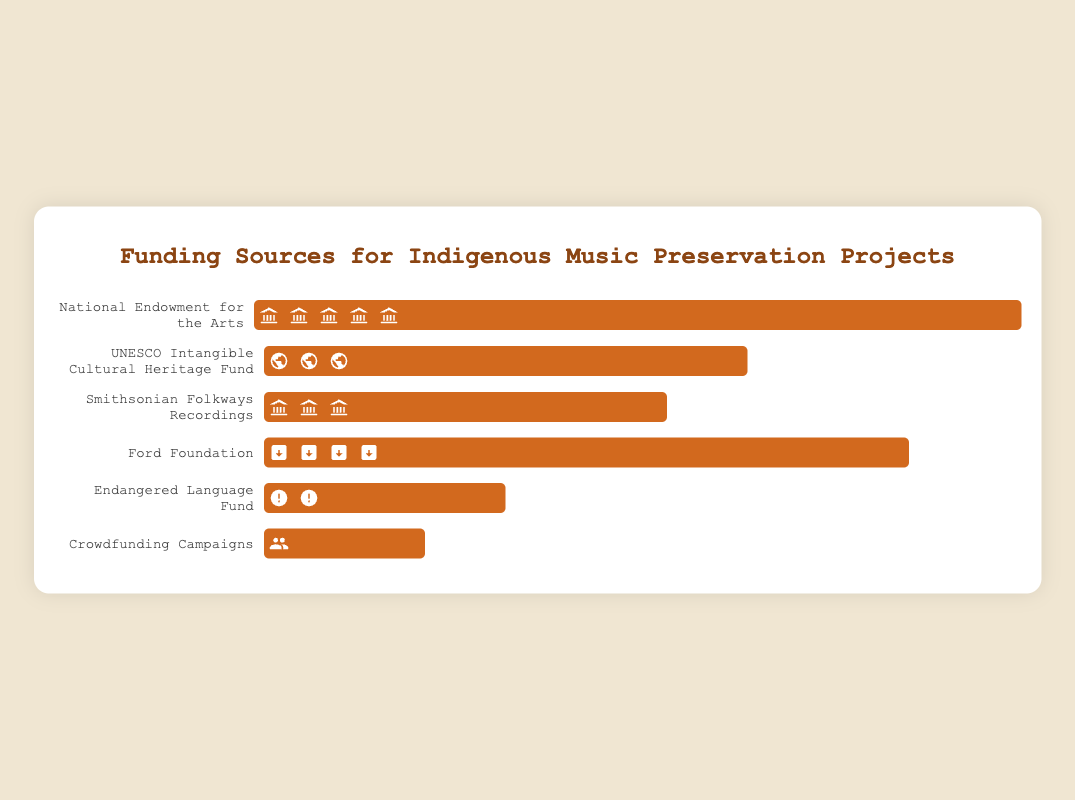What's the amount of funding provided by the National Endowment for the Arts? The bar related to the National Endowment for the Arts is the widest and corresponds to $500,000 according to the data provided.
Answer: $500,000 Which funding source provides the least amount of money? Comparing the lengths of the bars, the shortest one corresponds to Crowdfunding Campaigns, which has $100,000 as per the data provided.
Answer: Crowdfunding Campaigns How much more funding does the Ford Foundation provide compared to the Endangered Language Fund? The Ford Foundation provides $400,000 and the Endangered Language Fund provides $150,000. The difference is $400,000 - $150,000 = $250,000.
Answer: $250,000 If you combine the funding from Smithsonian Folkways Recordings and UNESCO Intangible Cultural Heritage Fund, what total amount do you get? The funding from Smithsonian Folkways Recordings is $250,000 and from UNESCO is $300,000. Combined, it is $250,000 + $300,000 =  $550,000.
Answer: $550,000 Which funding source uses an icon of a building with pillars? By looking at the bar labels and icons, the "institution" icon (building with pillars) corresponds to Smithsonian Folkways Recordings.
Answer: Smithsonian Folkways Recordings Rank the funding sources from highest to lowest amount of funding provided. The order from highest to lowest based on the bar lengths: National Endowment for the Arts ($500,000), Ford Foundation ($400,000), UNESCO Intangible Cultural Heritage Fund ($300,000), Smithsonian Folkways Recordings ($250,000), Endangered Language Fund ($150,000), Crowdfunding Campaigns ($100,000).
Answer: National Endowment for the Arts, Ford Foundation, UNESCO Intangible Cultural Heritage Fund, Smithsonian Folkways Recordings, Endangered Language Fund, Crowdfunding Campaigns How many funding sources provide at least $300,000? The bars representing funding sources providing at least $300,000 are from the National Endowment for the Arts, Ford Foundation, and UNESCO Intangible Cultural Heritage Fund, which are 3 in total.
Answer: 3 What is the total combined funding from all sources? Summing up all the provided amounts: $500,000 (National Endowment for the Arts) + $300,000 (UNESCO) + $250,000 (Smithsonian) + $400,000 (Ford) + $150,000 (Endangered Language Fund) + $100,000 (Crowdfunding) gives a total of $1,700,000.
Answer: $1,700,000 What's the ratio of funding between the National Endowment for the Arts and Crowdfunding Campaigns? The National Endowment for the Arts provides $500,000 and Crowdfunding Campaigns provide $100,000. The ratio is 500,000:100,000 which simplifies to 5:1.
Answer: 5:1 